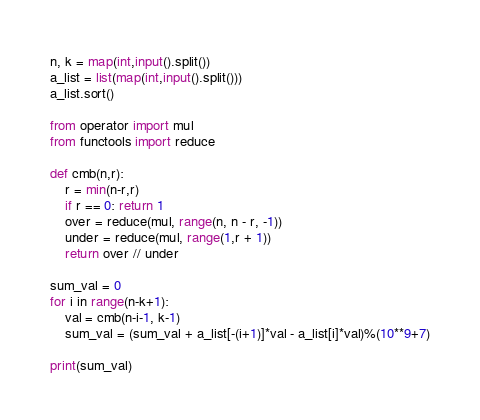Convert code to text. <code><loc_0><loc_0><loc_500><loc_500><_Python_>n, k = map(int,input().split())
a_list = list(map(int,input().split()))
a_list.sort()

from operator import mul
from functools import reduce

def cmb(n,r):
    r = min(n-r,r)
    if r == 0: return 1
    over = reduce(mul, range(n, n - r, -1))
    under = reduce(mul, range(1,r + 1))
    return over // under

sum_val = 0
for i in range(n-k+1):
    val = cmb(n-i-1, k-1)
    sum_val = (sum_val + a_list[-(i+1)]*val - a_list[i]*val)%(10**9+7)

print(sum_val)</code> 